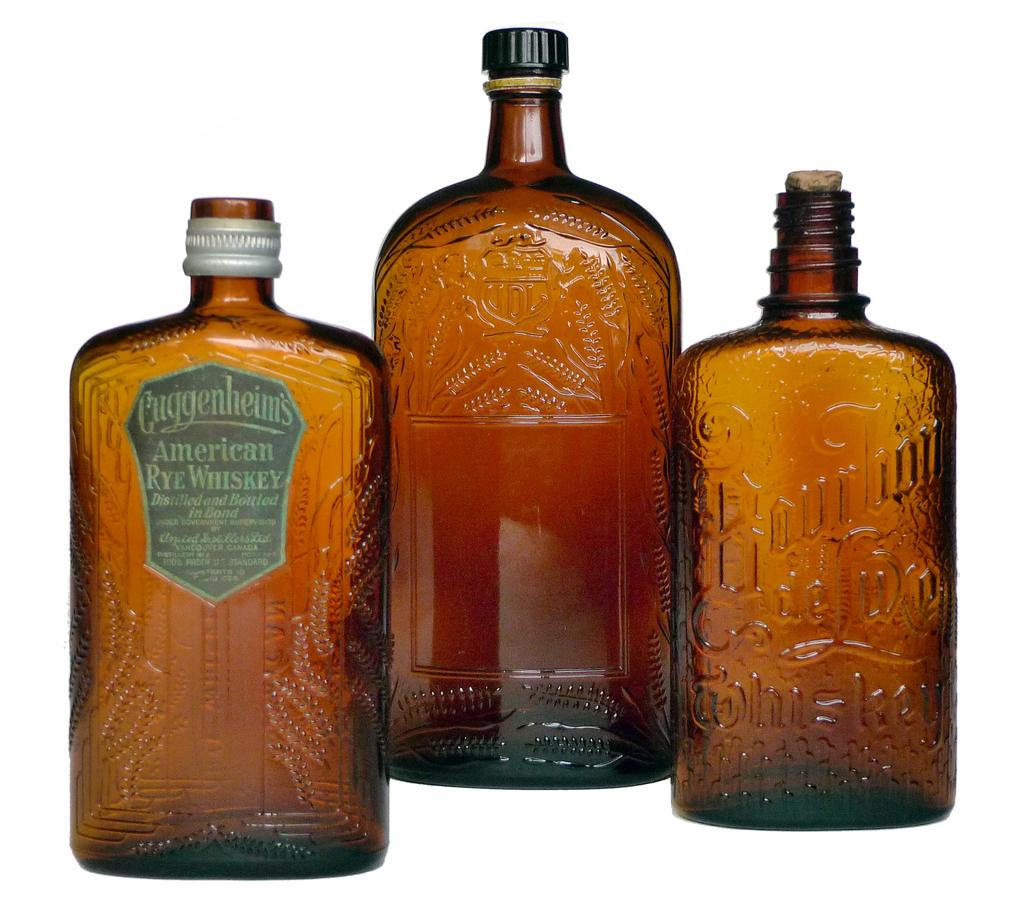Provide a one-sentence caption for the provided image. A bottle of Cuggenheims, American Rye Whiskey is next to two other bottles. 